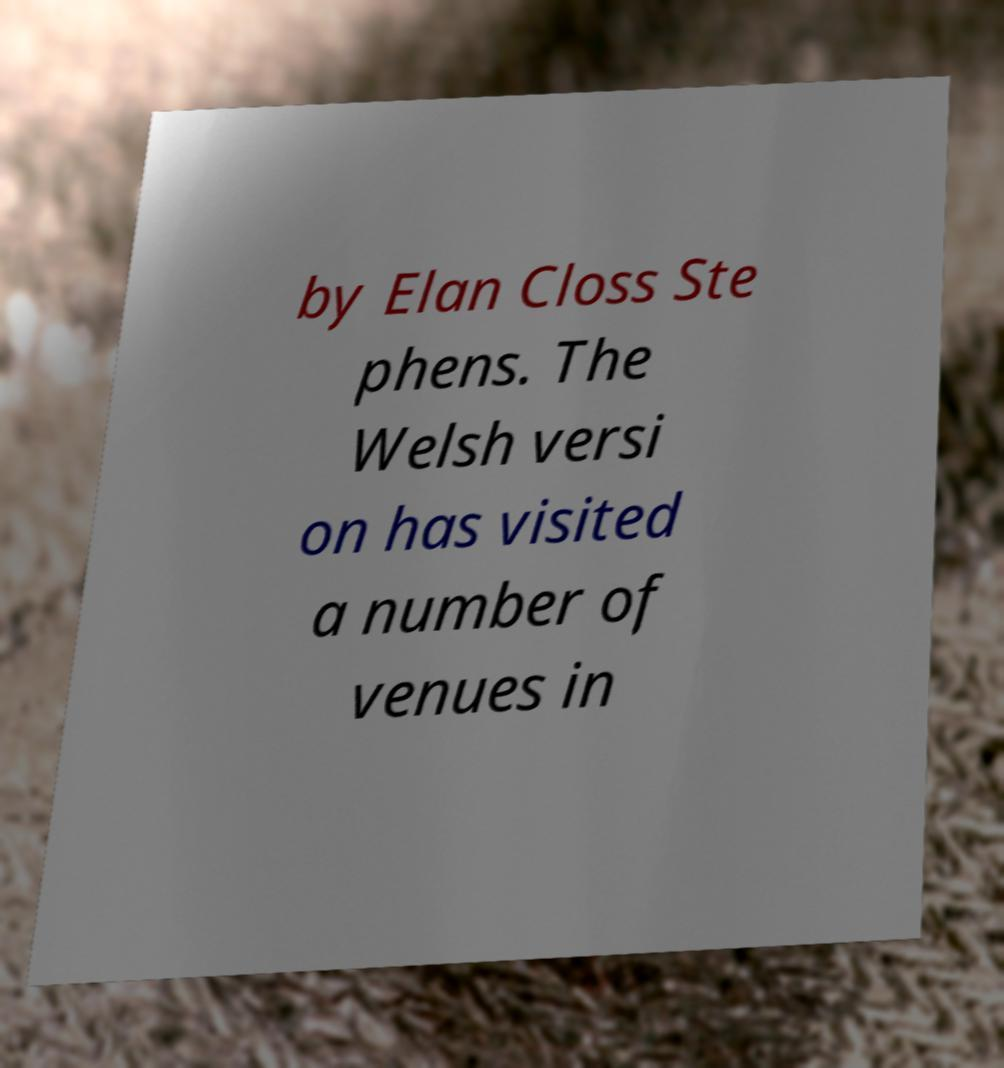Can you accurately transcribe the text from the provided image for me? by Elan Closs Ste phens. The Welsh versi on has visited a number of venues in 